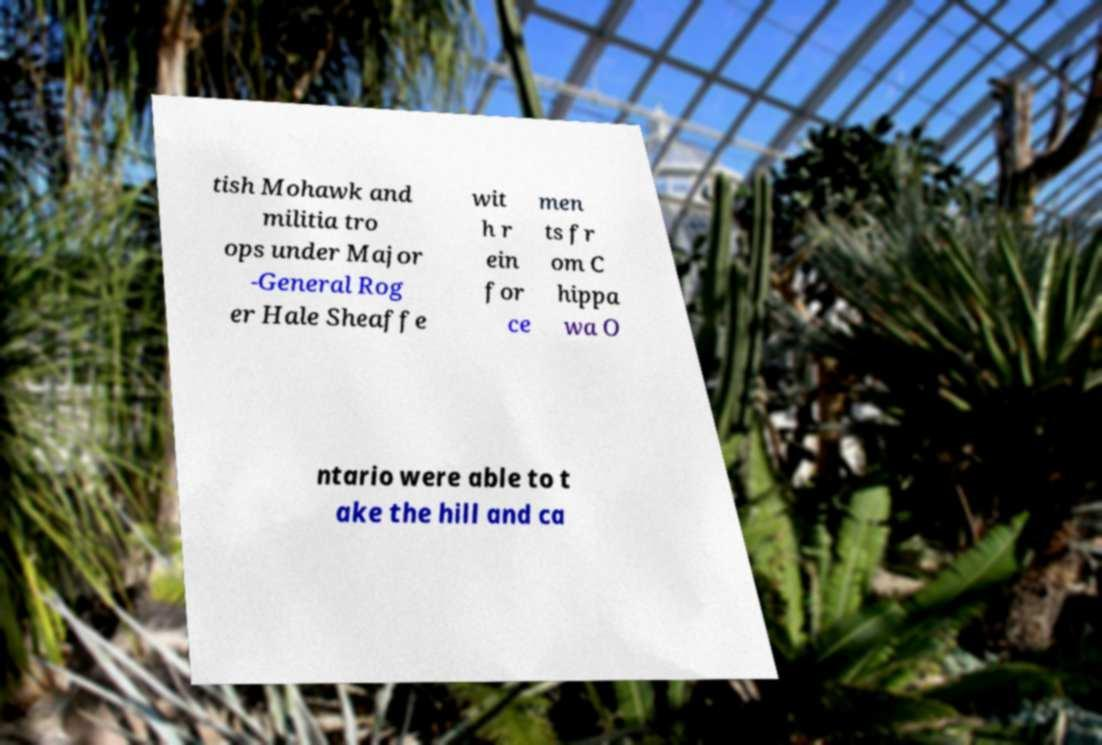Could you extract and type out the text from this image? tish Mohawk and militia tro ops under Major -General Rog er Hale Sheaffe wit h r ein for ce men ts fr om C hippa wa O ntario were able to t ake the hill and ca 